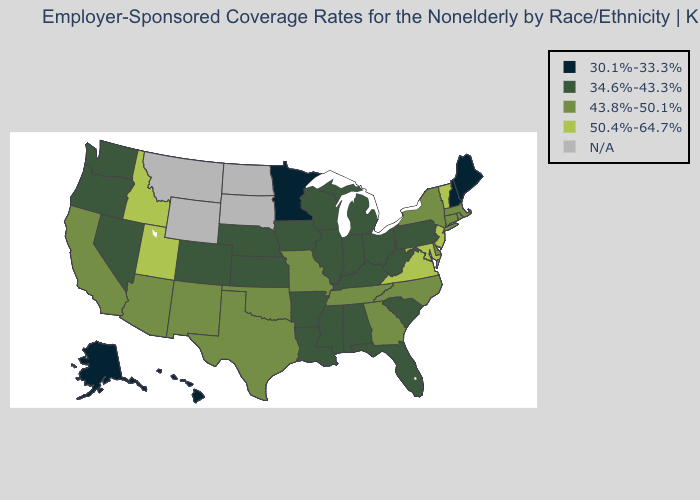Among the states that border West Virginia , does Virginia have the highest value?
Be succinct. Yes. What is the value of Michigan?
Short answer required. 34.6%-43.3%. Which states hav the highest value in the South?
Keep it brief. Maryland, Virginia. Name the states that have a value in the range N/A?
Give a very brief answer. Montana, North Dakota, South Dakota, Wyoming. Does New Jersey have the highest value in the Northeast?
Be succinct. Yes. Name the states that have a value in the range N/A?
Be succinct. Montana, North Dakota, South Dakota, Wyoming. Name the states that have a value in the range 50.4%-64.7%?
Short answer required. Idaho, Maryland, New Jersey, Utah, Vermont, Virginia. Does the map have missing data?
Short answer required. Yes. What is the lowest value in the Northeast?
Short answer required. 30.1%-33.3%. Which states hav the highest value in the West?
Keep it brief. Idaho, Utah. Among the states that border Wyoming , which have the lowest value?
Concise answer only. Colorado, Nebraska. Name the states that have a value in the range 43.8%-50.1%?
Give a very brief answer. Arizona, California, Connecticut, Delaware, Georgia, Massachusetts, Missouri, New Mexico, New York, North Carolina, Oklahoma, Rhode Island, Tennessee, Texas. What is the value of Vermont?
Answer briefly. 50.4%-64.7%. Among the states that border Oregon , does Washington have the lowest value?
Keep it brief. Yes. 